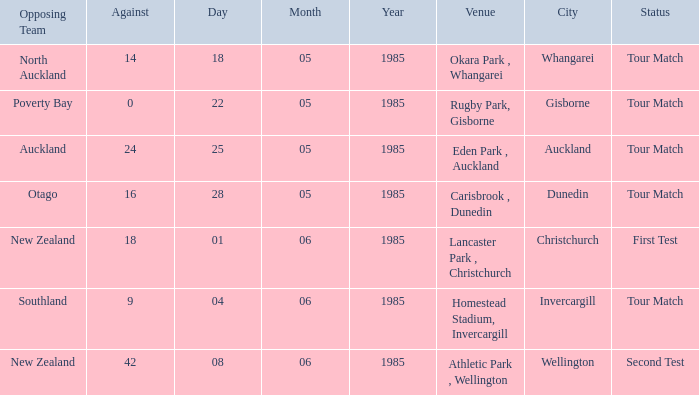Which opposing team had an Against score less than 42 and a Tour Match status in Rugby Park, Gisborne? Poverty Bay. 